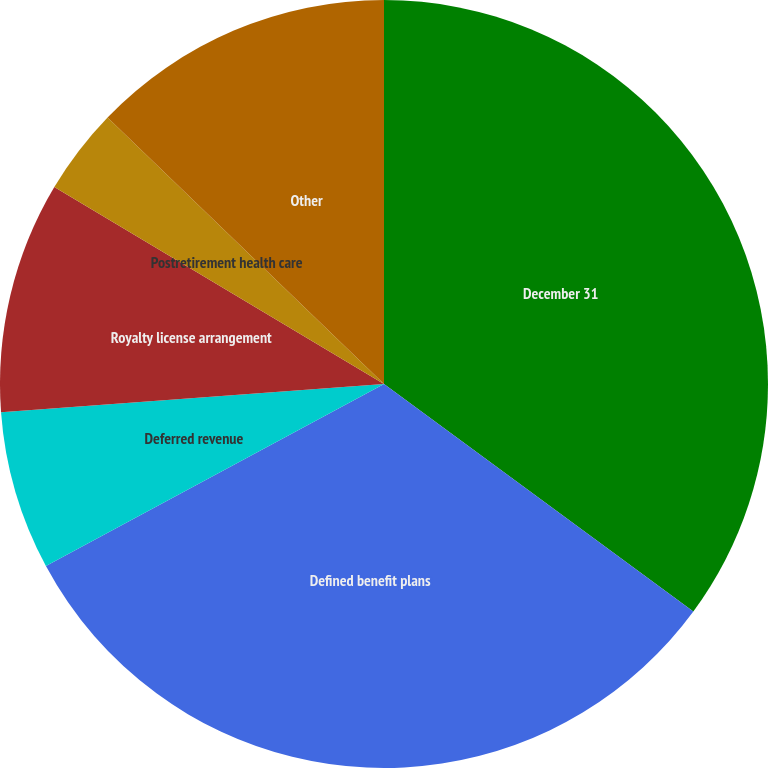<chart> <loc_0><loc_0><loc_500><loc_500><pie_chart><fcel>December 31<fcel>Defined benefit plans<fcel>Deferred revenue<fcel>Royalty license arrangement<fcel>Postretirement health care<fcel>Other<nl><fcel>35.09%<fcel>32.04%<fcel>6.69%<fcel>9.74%<fcel>3.64%<fcel>12.79%<nl></chart> 